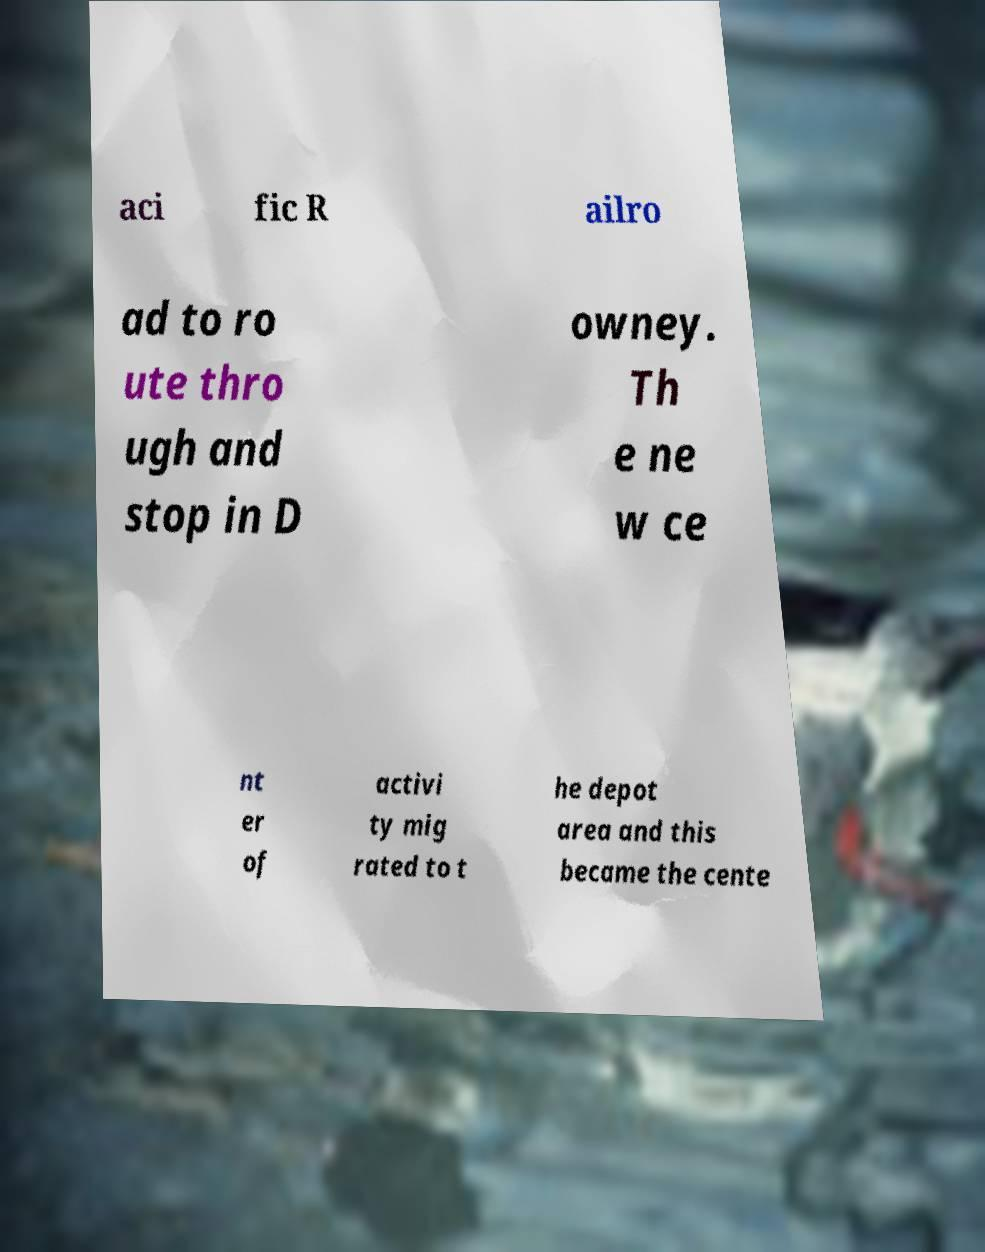What messages or text are displayed in this image? I need them in a readable, typed format. aci fic R ailro ad to ro ute thro ugh and stop in D owney. Th e ne w ce nt er of activi ty mig rated to t he depot area and this became the cente 